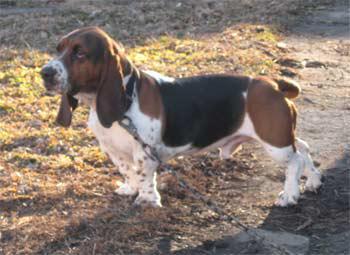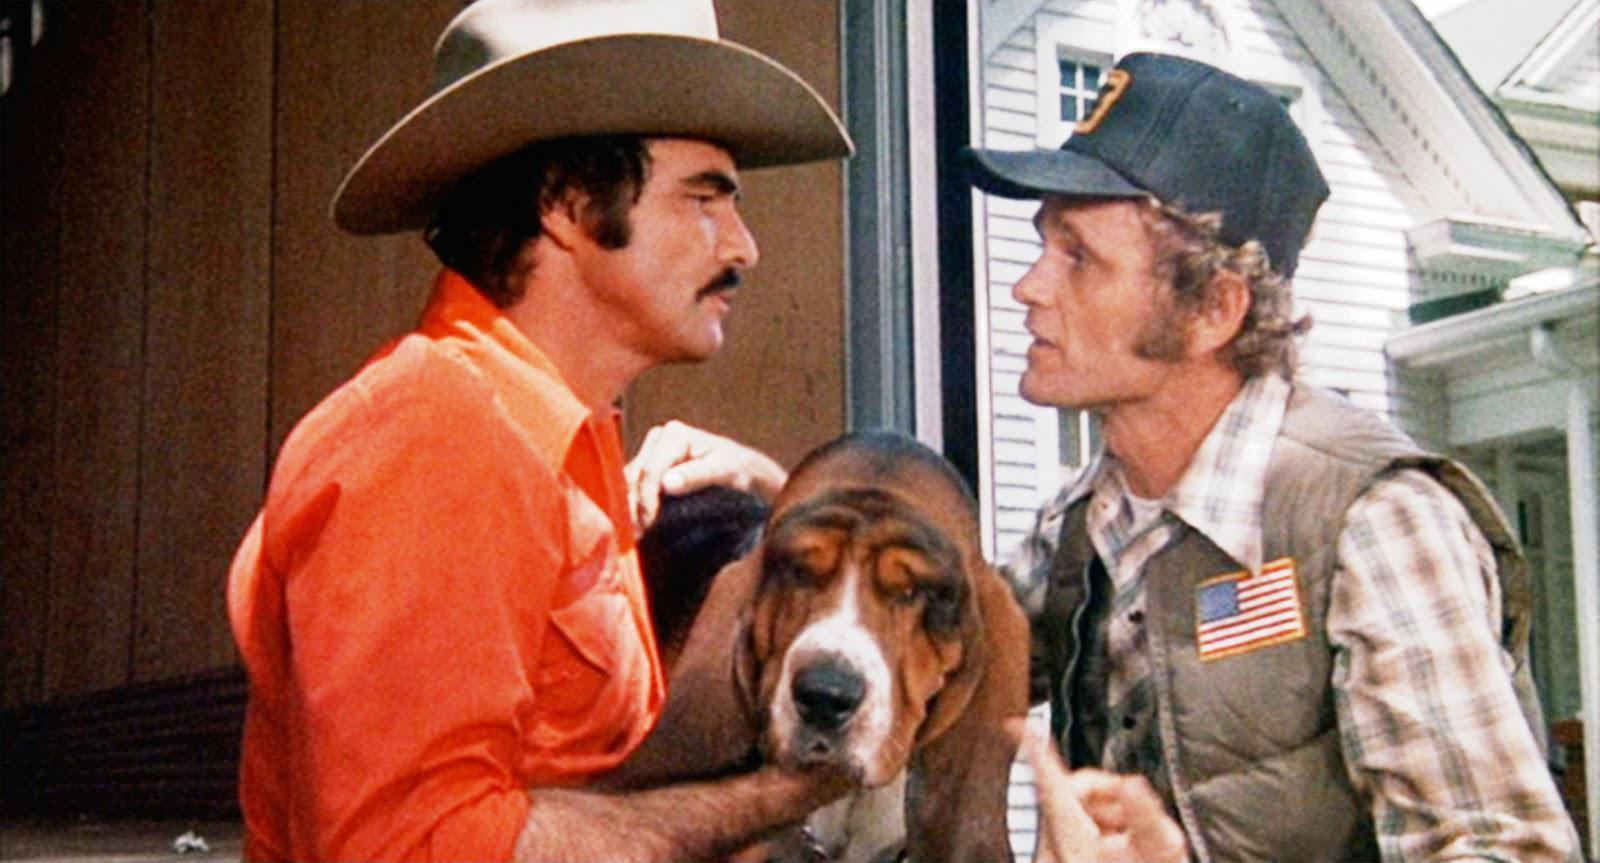The first image is the image on the left, the second image is the image on the right. Considering the images on both sides, is "One image with at least one camera-facing basset hound in it also contains two hats." valid? Answer yes or no. Yes. 